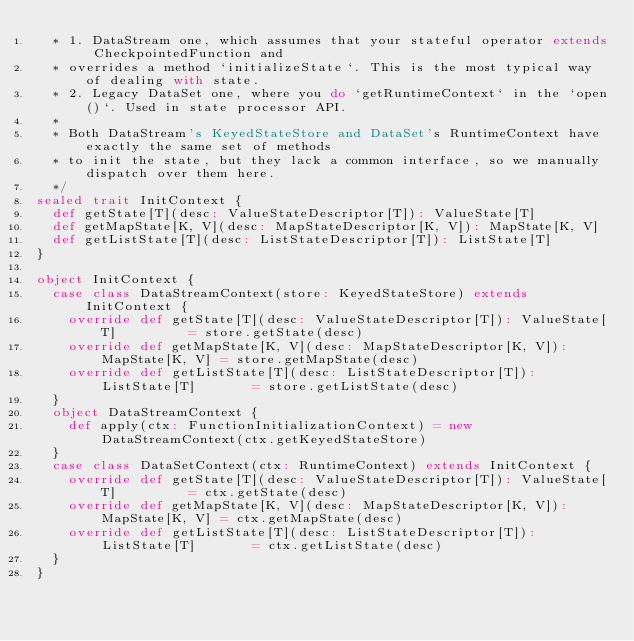<code> <loc_0><loc_0><loc_500><loc_500><_Scala_>  * 1. DataStream one, which assumes that your stateful operator extends CheckpointedFunction and
  * overrides a method `initializeState`. This is the most typical way of dealing with state.
  * 2. Legacy DataSet one, where you do `getRuntimeContext` in the `open()`. Used in state processor API.
  *
  * Both DataStream's KeyedStateStore and DataSet's RuntimeContext have exactly the same set of methods
  * to init the state, but they lack a common interface, so we manually dispatch over them here.
  */
sealed trait InitContext {
  def getState[T](desc: ValueStateDescriptor[T]): ValueState[T]
  def getMapState[K, V](desc: MapStateDescriptor[K, V]): MapState[K, V]
  def getListState[T](desc: ListStateDescriptor[T]): ListState[T]
}

object InitContext {
  case class DataStreamContext(store: KeyedStateStore) extends InitContext {
    override def getState[T](desc: ValueStateDescriptor[T]): ValueState[T]         = store.getState(desc)
    override def getMapState[K, V](desc: MapStateDescriptor[K, V]): MapState[K, V] = store.getMapState(desc)
    override def getListState[T](desc: ListStateDescriptor[T]): ListState[T]       = store.getListState(desc)
  }
  object DataStreamContext {
    def apply(ctx: FunctionInitializationContext) = new DataStreamContext(ctx.getKeyedStateStore)
  }
  case class DataSetContext(ctx: RuntimeContext) extends InitContext {
    override def getState[T](desc: ValueStateDescriptor[T]): ValueState[T]         = ctx.getState(desc)
    override def getMapState[K, V](desc: MapStateDescriptor[K, V]): MapState[K, V] = ctx.getMapState(desc)
    override def getListState[T](desc: ListStateDescriptor[T]): ListState[T]       = ctx.getListState(desc)
  }
}
</code> 